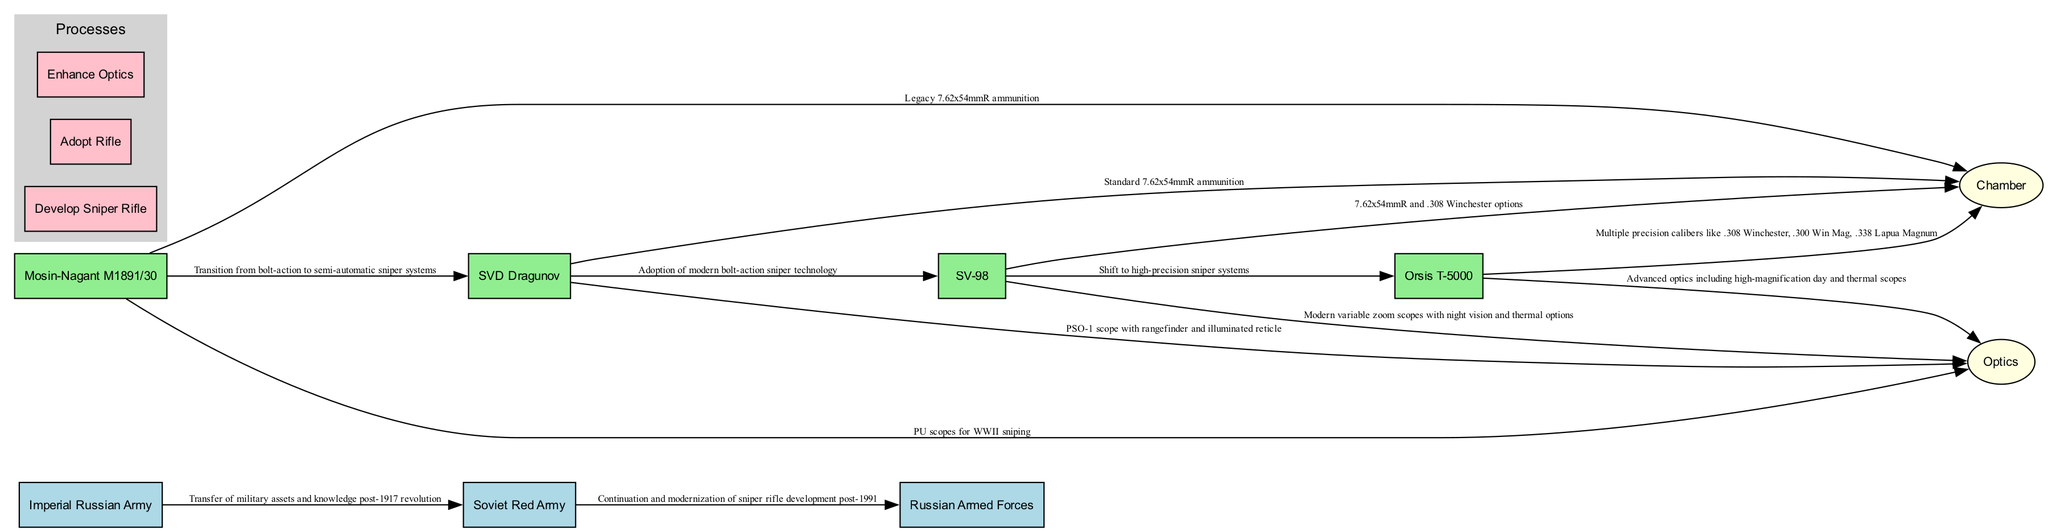What is the last sniper rifle mentioned in the diagram? The last entity in the flow of sniper rifles is "Orsis T-5000", which appears at the end of the series of developments.
Answer: Orsis T-5000 What are the two types of chambers associated with the SVD Dragunov? The SVD Dragunov is associated with "Standard 7.62x54mmR ammunition" and the description of "Chamber", which connects the rifle to its ammunition type.
Answer: Standard 7.62x54mmR ammunition Which military force is directly linked to the Mosin-Nagant M1891/30? The "Soviet Red Army" is directly linked to the Mosin-Nagant M1891/30 via a flow that indicates the continuation of its use and development after World War I.
Answer: Soviet Red Army What is the total number of sniper rifles depicted in the diagram? The diagram shows a total of four sniper rifles: Mosin-Nagant M1891/30, SVD Dragunov, SV-98, and Orsis T-5000, thus summing them up gives the total count.
Answer: 4 How many processes are defined in the diagram? There are three processes listed in the diagram which are: "Develop Sniper Rifle", "Adopt Rifle", and "Enhance Optics". Therefore, the total number of processes is determined from the cluster.
Answer: 3 What type of optics is associated with the newly adopted SV-98? The SV-98 is associated with "Modern variable zoom scopes with night vision and thermal options", indicating the advancement in visual technology for snipers.
Answer: Modern variable zoom scopes with night vision and thermal options Which sniper rifle marks the transition from bolt-action to semi-automatic systems? The transition from a bolt-action rifle to a semi-automatic sniper system is marked by the "SVD Dragunov", which is linked to the Mosin-Nagant M1891/30.
Answer: SVD Dragunov What type of relationship exists between the Orsis T-5000 and high-precision sniper systems? The relationship indicates a "Shift to high-precision sniper systems", portraying the evolution in technology and capabilities of sniper rifles over time.
Answer: Shift to high-precision sniper systems 